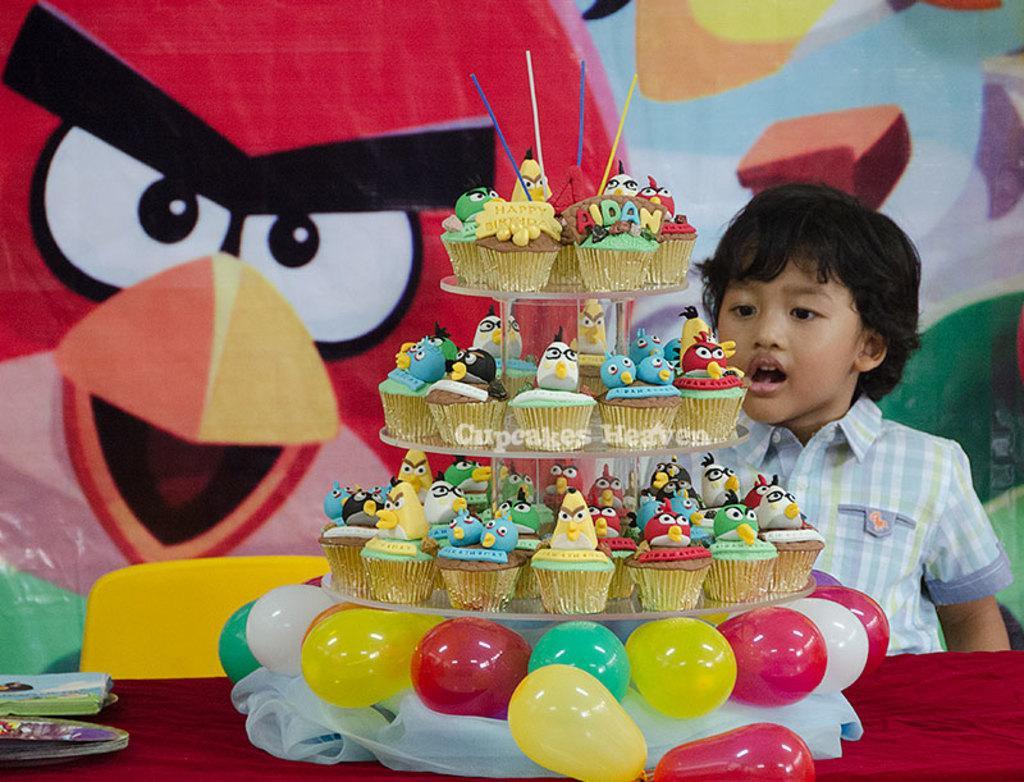Could you give a brief overview of what you see in this image? In the image there are a lot of cupcakes and below the cupcakes there are balloons, there is a boy standing in front of the table and behind the boy the wall is painted with different pictures and there is a yellow chair in front of the table. 